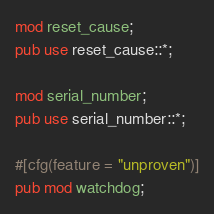Convert code to text. <code><loc_0><loc_0><loc_500><loc_500><_Rust_>mod reset_cause;
pub use reset_cause::*;

mod serial_number;
pub use serial_number::*;

#[cfg(feature = "unproven")]
pub mod watchdog;
</code> 